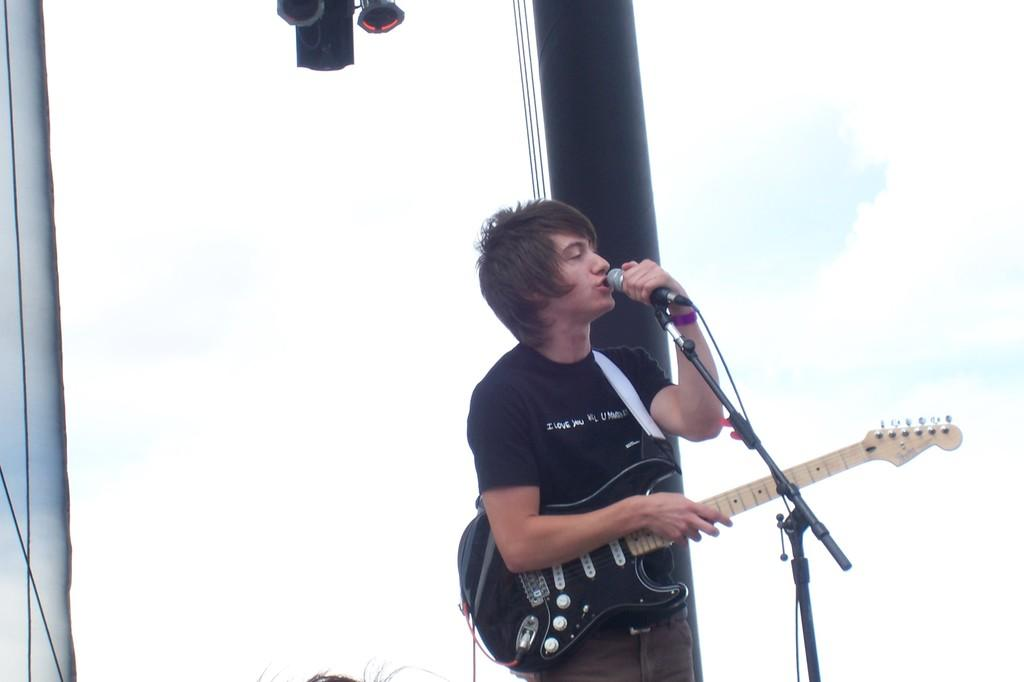What is the man in the image doing? The man is holding a guitar, singing, and is in front of a microphone. What object is the man holding in the image? The man is holding a guitar. What is the man standing in front of in the image? The man is standing in front of a microphone. What can be seen in the background of the image? There is a window in the background of the image. What type of crown is the man wearing in the image? There is no crown present in the image; the man is simply holding a guitar and singing. Is the man holding a bottle in the image? No, the man is not holding a bottle in the image; he is holding a guitar. 